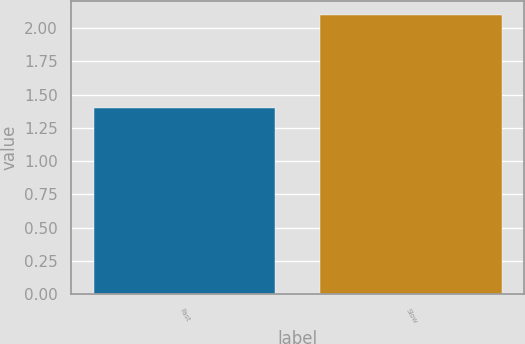<chart> <loc_0><loc_0><loc_500><loc_500><bar_chart><fcel>Fast<fcel>Slow<nl><fcel>1.4<fcel>2.1<nl></chart> 